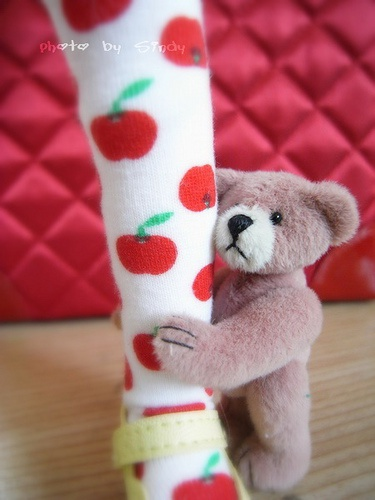Describe the objects in this image and their specific colors. I can see people in maroon, lightgray, darkgray, brown, and salmon tones, teddy bear in maroon, darkgray, gray, and brown tones, apple in maroon, brown, salmon, and red tones, apple in maroon, salmon, red, and brown tones, and apple in maroon, salmon, and red tones in this image. 